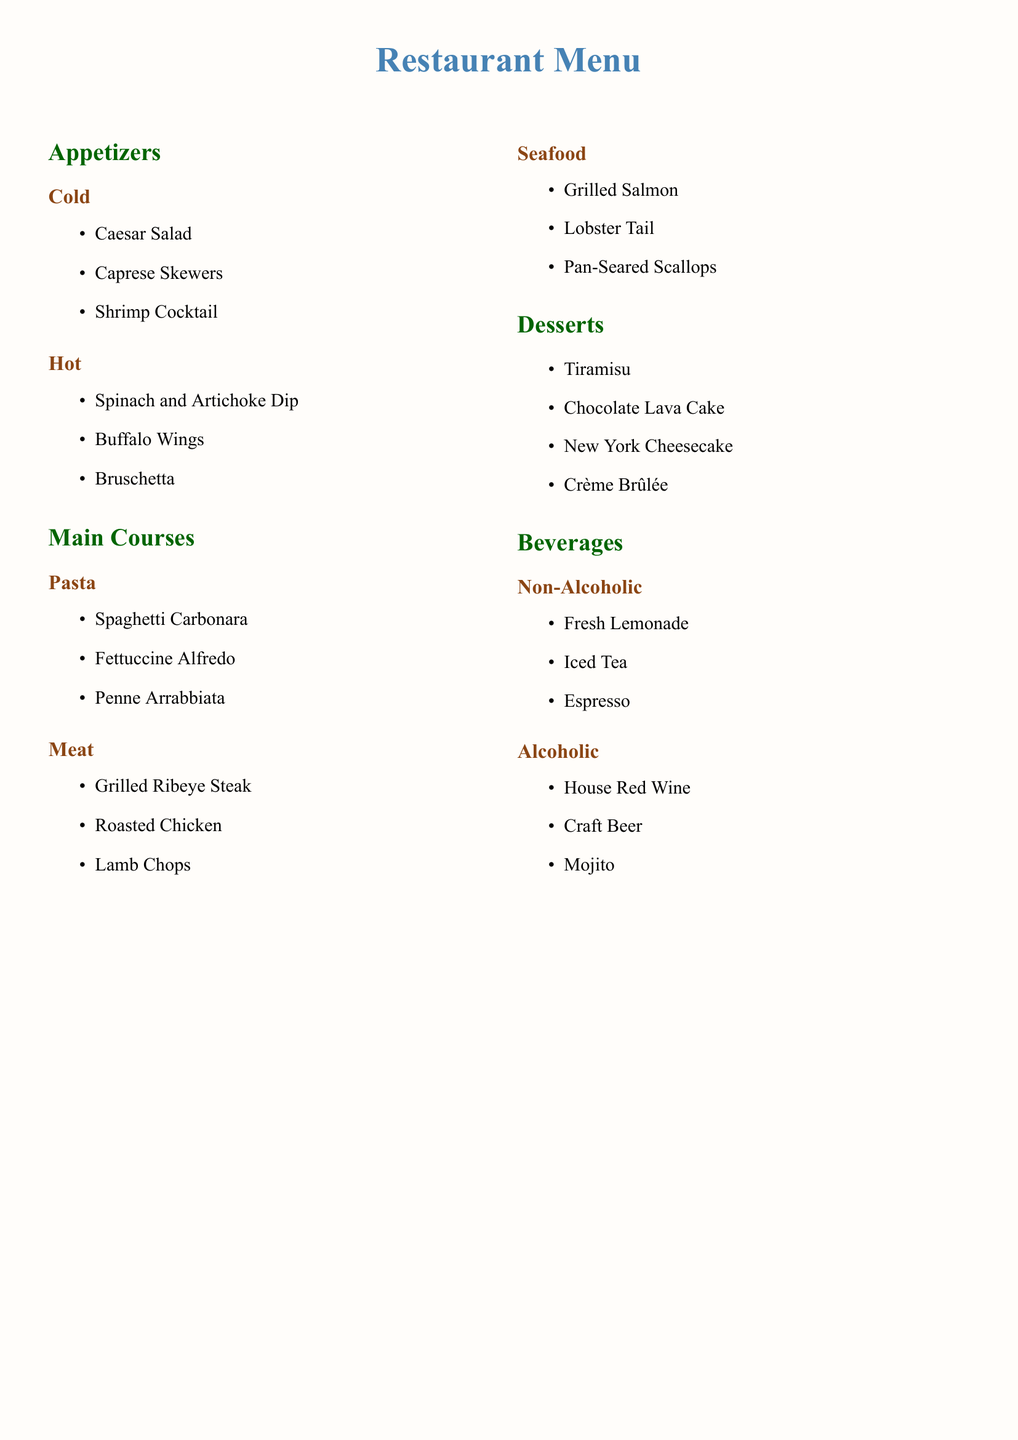What is the first dish listed under Cold Appetizers? The first dish in the Cold category is mentioned first in the list of items under Cold Appetizers.
Answer: Caesar Salad How many subcategories are there under Main Courses? The number of subcategories can be counted from the Main Courses section of the menu.
Answer: 3 Which dessert is known for its creamy texture and caramelized top? The dessert with a creamy texture and a caramelized top is listed last in the Desserts section.
Answer: Crème Brûlée What is the last beverage listed under Alcoholic drinks? The last item under the Alcoholic drinks category can be derived from the list provided in that section.
Answer: Mojito Name one dish from the Seafood subcategory. Any dish in the Seafood subcategory can be named directly from the list of items there.
Answer: Grilled Salmon How many total appetizers are listed in the menu? The total number of appetizers can be calculated by adding the items in both Cold and Hot subcategories.
Answer: 6 What is the color of the title in the document? The color representing the title is specified in the document.
Answer: RGB(70,130,180) Which main course is described as containing pasta? The main course category with pasta refers to the specific subcategory described in the document.
Answer: Pasta What is the highest number of items listed in any single subcategory? This can be concluded by checking the number of items listed across the subcategories.
Answer: 3 